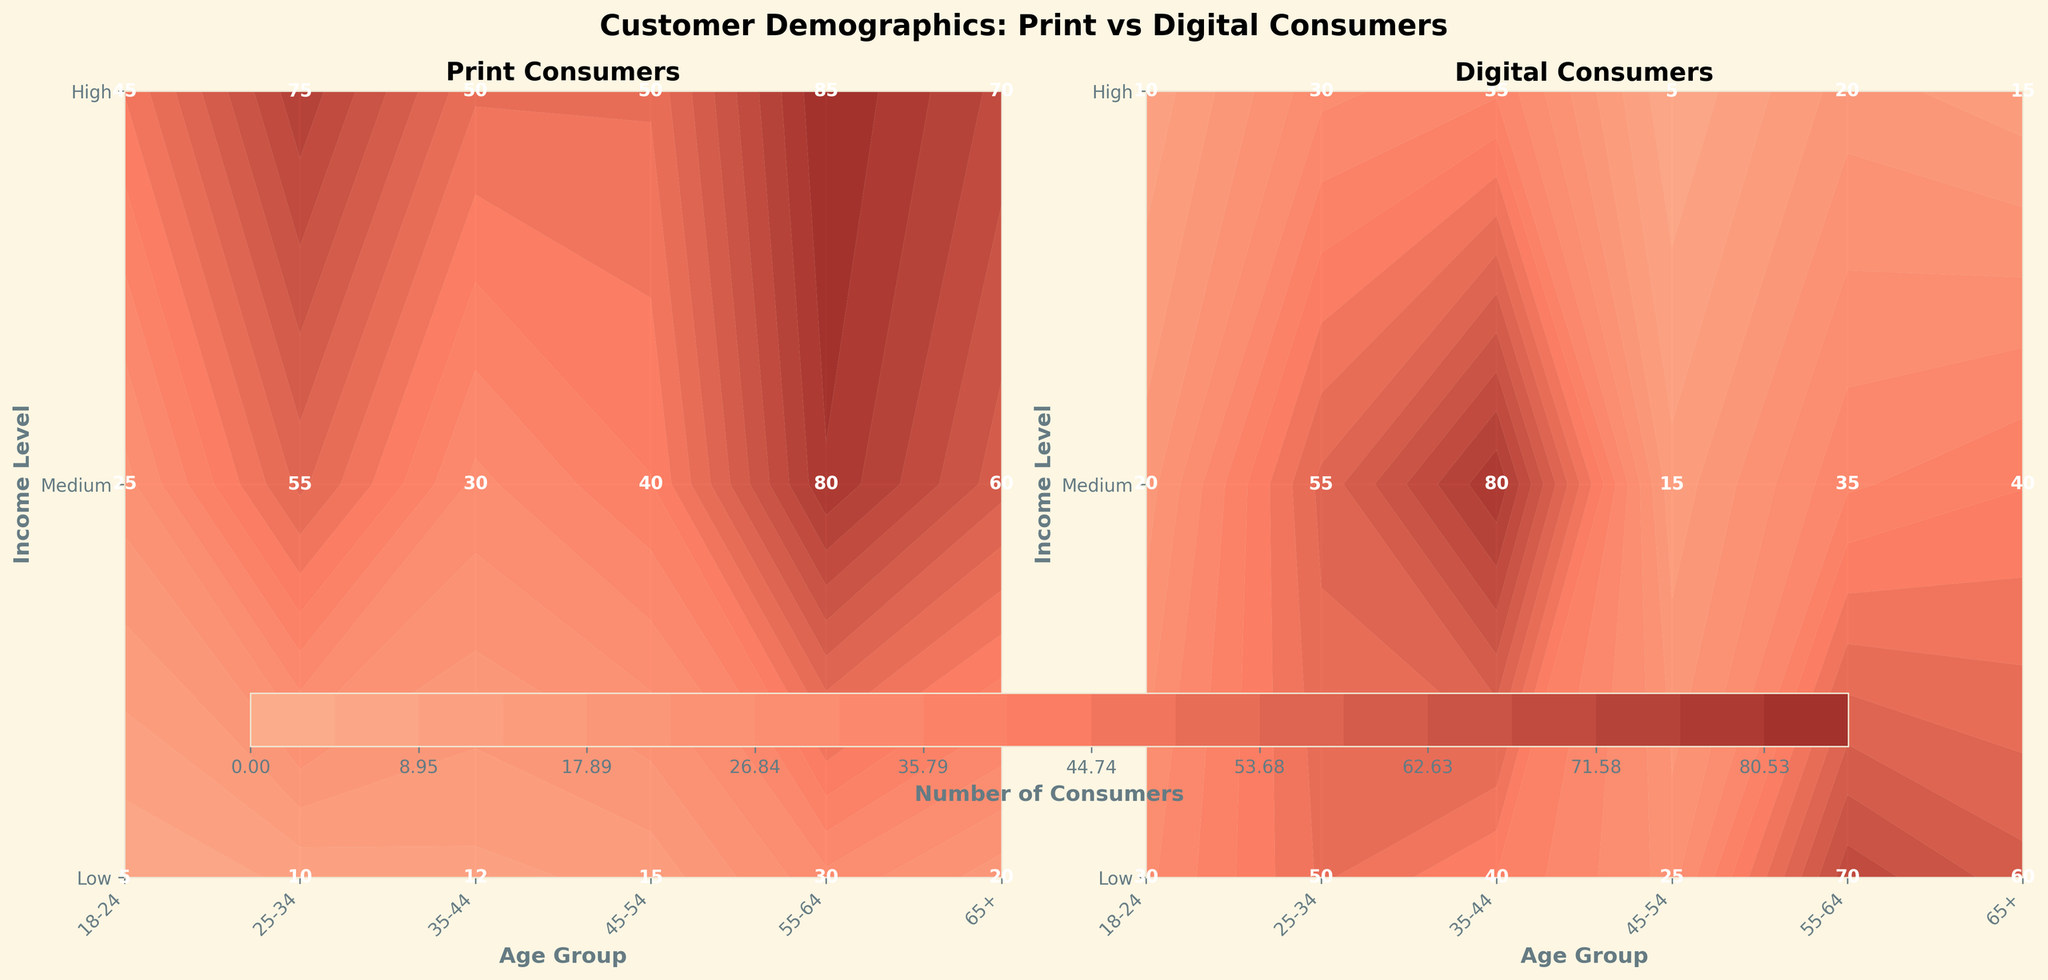What is the title of the figure? The title is typically placed at the top of the figure, and in this case, it reads "Customer Demographics: Print vs Digital Consumers."
Answer: Customer Demographics: Print vs Digital Consumers What age group and income level has the highest number of digital consumers? Looking at the "Digital Consumers" plot, the highest value is labeled within the grid of the "35-44" age group and "High" income level.
Answer: 35-44, High Which demographic has the lowest number of print consumers? Referring to the "Print Consumers" plot, the lowest value is labeled within the grid of the "18-24" age group and "Low" income level.
Answer: 18-24, Low How many medium income print consumers are in the 25-34 age range? In the "Print Consumers" plot, locate the grid intersecting "25-34" age group and "Medium" income level, labeled with the value "30."
Answer: 30 Compare the number of print and digital consumers for the "65+, Low" demographic. Locate the "65+, Low" grid for both plots. The values are labeled as "50" for print and "5" for digital. The difference is 50 - 5 = 45.
Answer: Print has 45 more consumers What is the difference in the number of print consumers between the 45-54 and 55-64 age groups with high income? Locate the grids for "High" income within both "45-54" and "55-64" age groups in the "Print Consumers" plot, labeled as "60" and "50" respectively. The difference is 60 - 50 = 10.
Answer: 10 What is the average number of digital consumers in the 35-44 age group? Sum the digital consumer values within the "35-44" age group: 20 (Low) + 55 (Medium) + 80 (High) = 155. Divide by the number of values, which is 3, to get the average: 155 / 3 ≈ 51.67.
Answer: ≈ 51.67 In which age group and income level do digital consumers significantly outnumber print consumers? Referring to both plots, the "18-24, Low" grid stands out where digital consumers (30) significantly exceed print consumers (5).
Answer: 18-24, Low Identify an age group where the number of digital consumers decreases as the income level increases. Reviewing the "Digital Consumers" plot, the "65+" age group shows this pattern: low income (5), medium income (20), and high income (15).
Answer: 65+ Between the medium income groups across all ages, which age group has the highest number of print consumers? In the "Print Consumers" plot, compare the "Medium" income level across all age groups. The highest value is labeled within the "45-54" age group, which is "80."
Answer: 45-54 